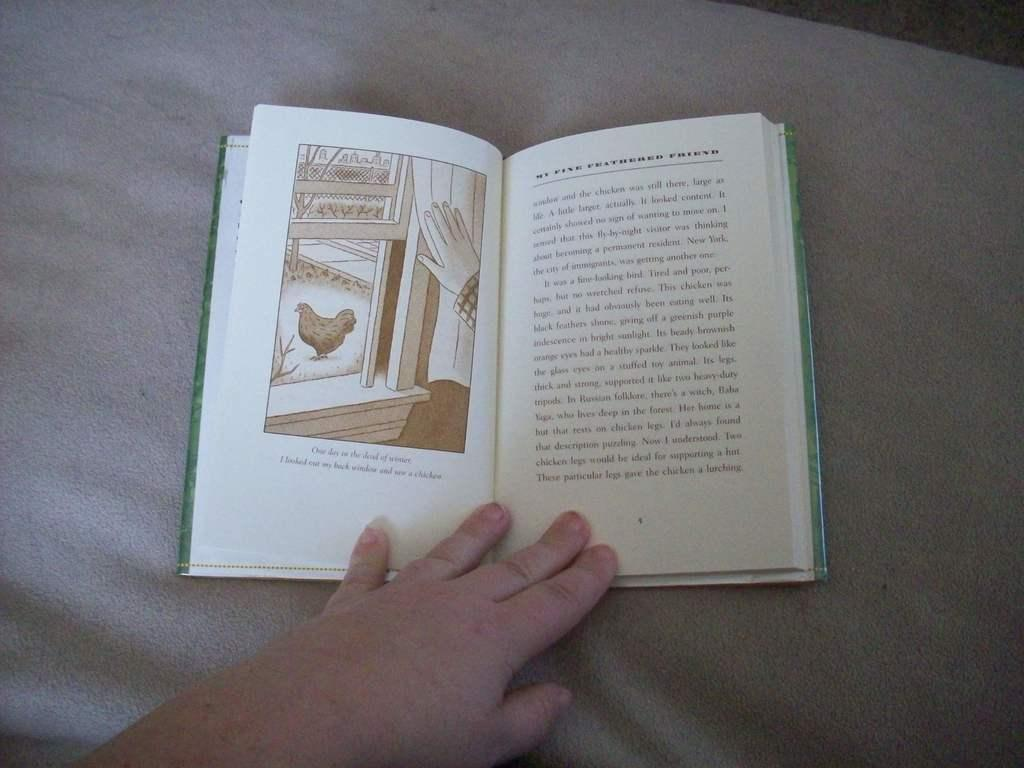<image>
Provide a brief description of the given image. A book opened to the page 5 on the right 